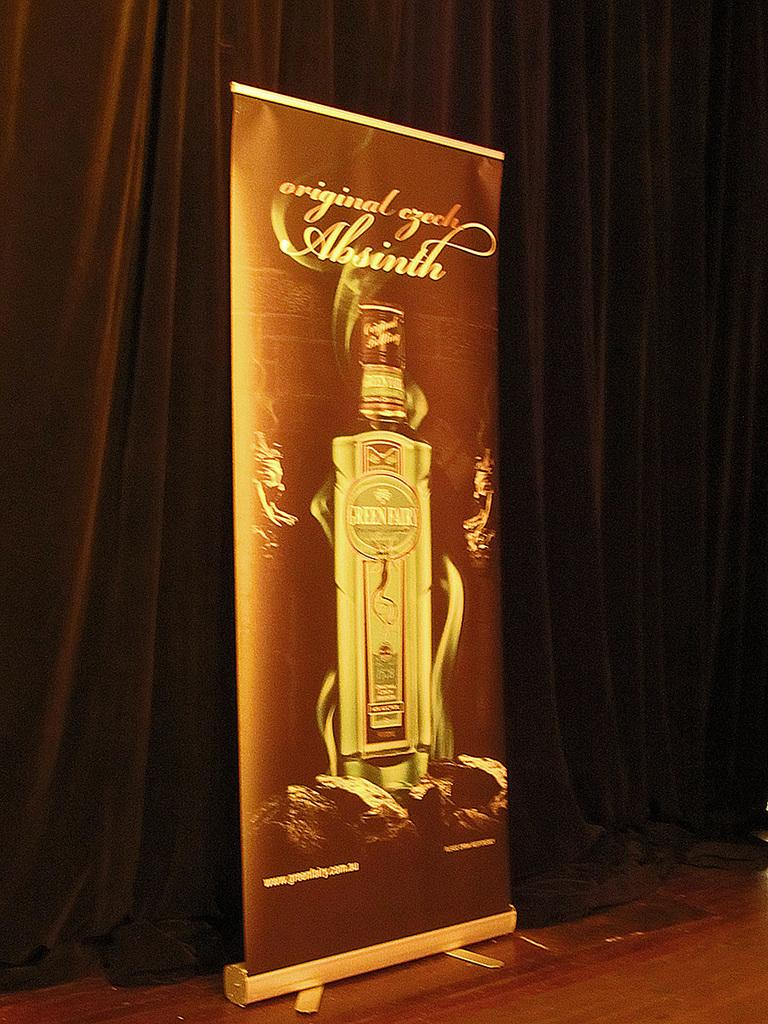Provide a one-sentence caption for the provided image. A large promotional poster for Absinth stands in front of a brown curtain. 